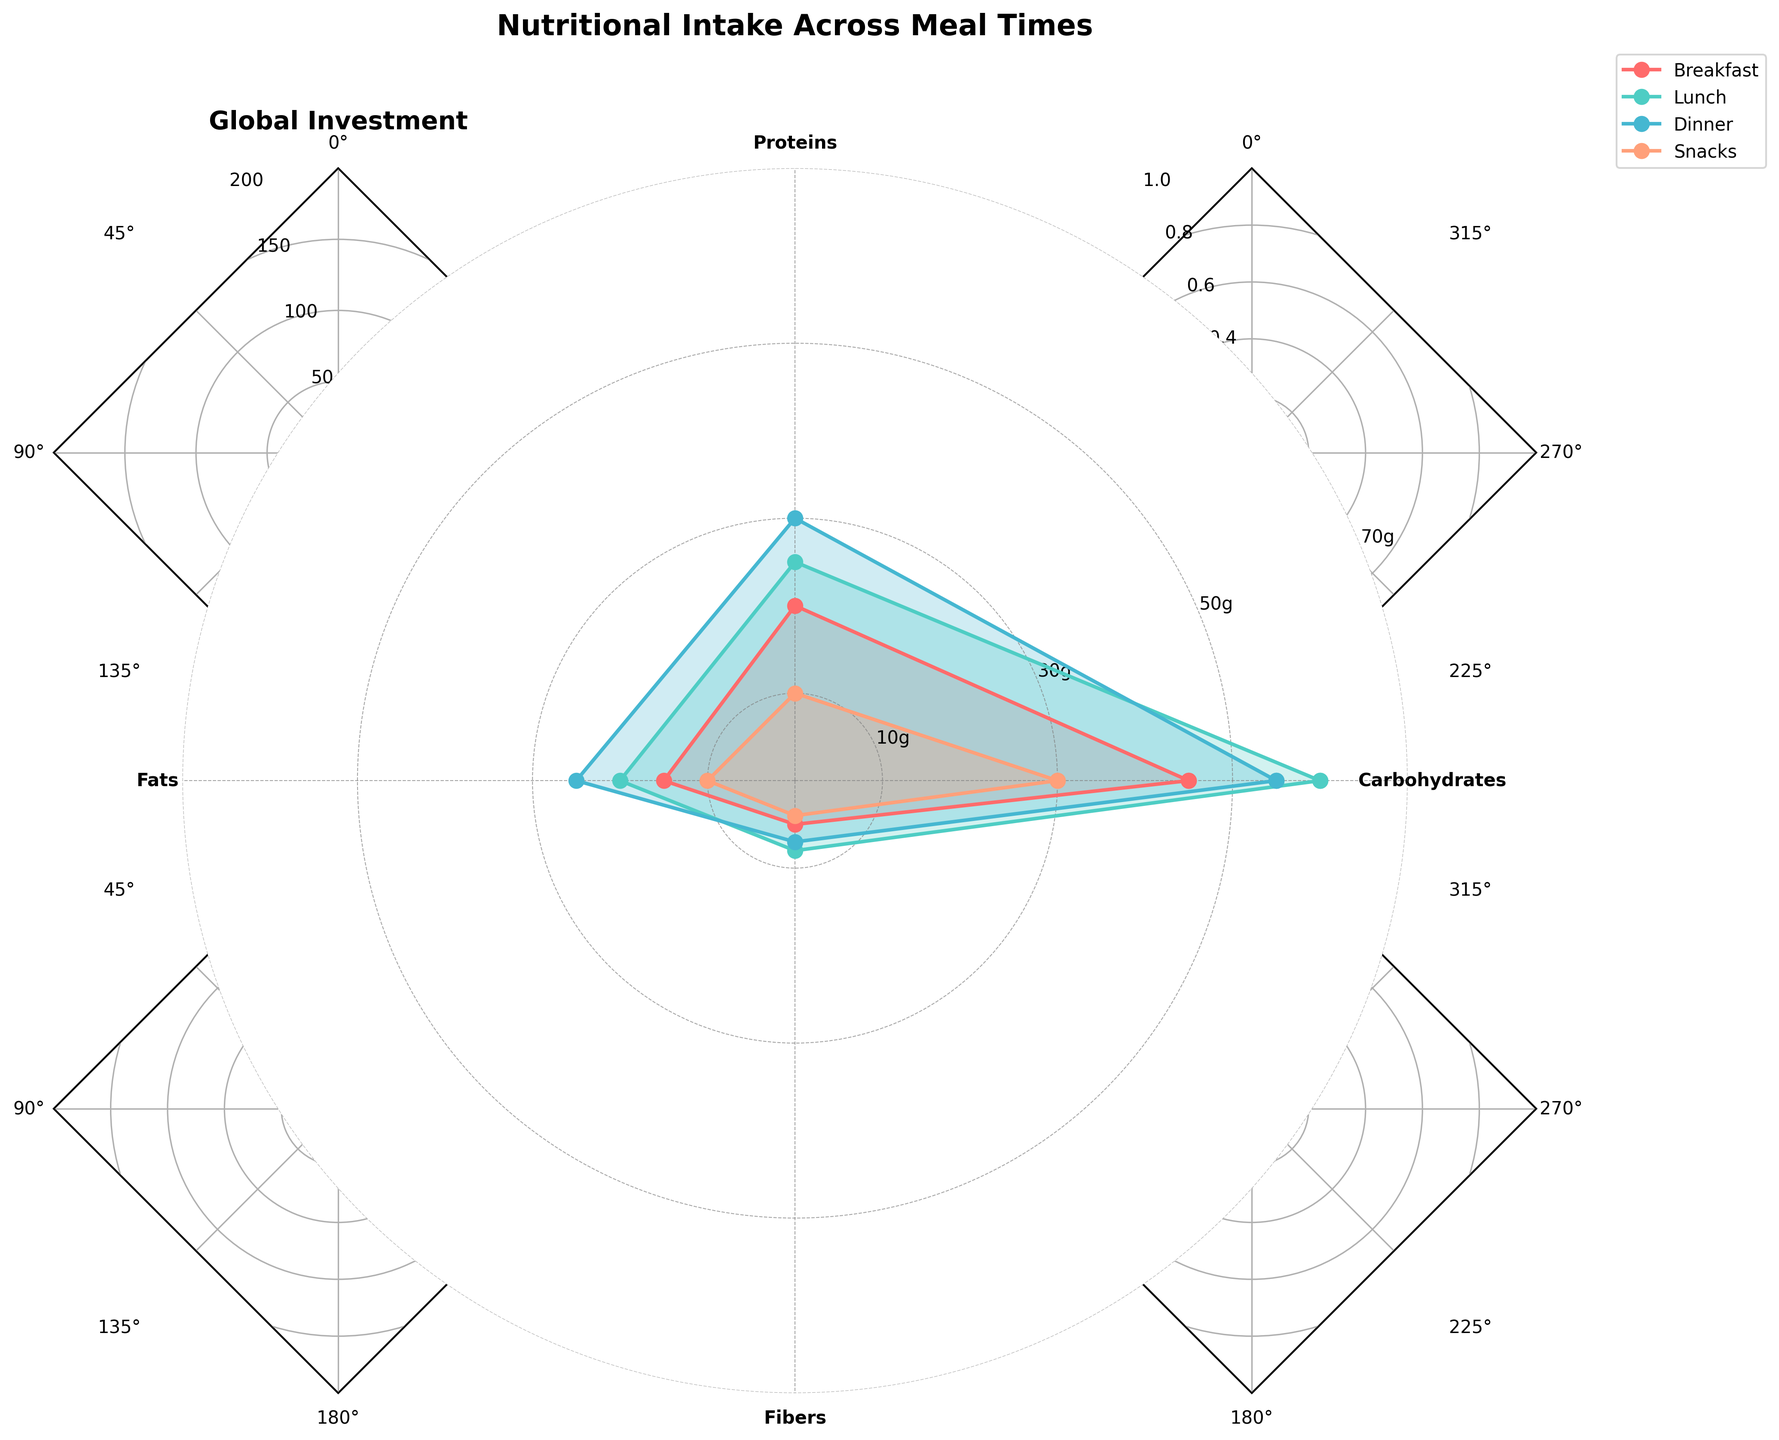What is the title of the chart? The title of the chart is usually prominently displayed at the top of the figure.
Answer: Nutritional Intake Across Meal Times How many categories of nutrients are analyzed in the chart? By counting the number of labeled axes stemming from the center of the radar chart, you can find the number of nutrient categories.
Answer: Four Which meal time has the highest intake of carbohydrates? Each meal time's carbohydrate consumption can be identified from one of the axes. By comparing the lengths of lines corresponding to carbohydrates, we see that Lunch has the longest line.
Answer: Lunch What is the difference between the protein intake at breakfast and dinner? Check the length of the proteins line for both breakfast and dinner. Dinner's protein intake is 30, while breakfast's is 20. Subtract the smaller number from the larger.
Answer: 10 Which meal time has the lowest fiber intake? Compare the lengths of the lines corresponding to fiber intake for each meal time. Snacks have the shortest line for fiber intake (4).
Answer: Snacks What is the average fat intake across all meal times? Add the fat intake values of all meal times and divide by the number of meal times: (15 + 20 + 25 + 10) / 4
Answer: 17.5 Compare the overall nutrient intake (sum of all categories) between lunch and dinner. Which has the higher overall intake? Sum the intake values for lunch (60+25+20+8 = 113) and dinner (55+30+25+7 = 117). Dinner has the higher overall intake.
Answer: Dinner Which two meal times have the most similar carbohydrate intake? Compare the carbohydrate intake values for all pairs. Both breakfast (45) and dinner (55) are closest.
Answer: Breakfast and Dinner Are fibers more evenly distributed or do they show significant differences across meal times? Assess the variation among the fiber values (5, 8, 7, 4). They show significant differences due to the distinct values.
Answer: Significant differences Which nutrient shows the largest intake variability across different meal times? Examine the range of each nutrient category (carbohydrates: 60-30=30, proteins: 30-10=20, fats: 25-10=15, fibers: 8-4=4). Carbohydrates show the largest variability.
Answer: Carbohydrates 